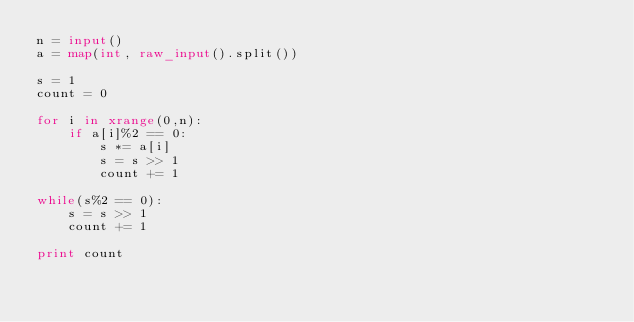Convert code to text. <code><loc_0><loc_0><loc_500><loc_500><_Python_>n = input()
a = map(int, raw_input().split())

s = 1
count = 0

for i in xrange(0,n):
	if a[i]%2 == 0:
		s *= a[i]
		s = s >> 1
		count += 1

while(s%2 == 0):
	s = s >> 1
	count += 1

print count
</code> 